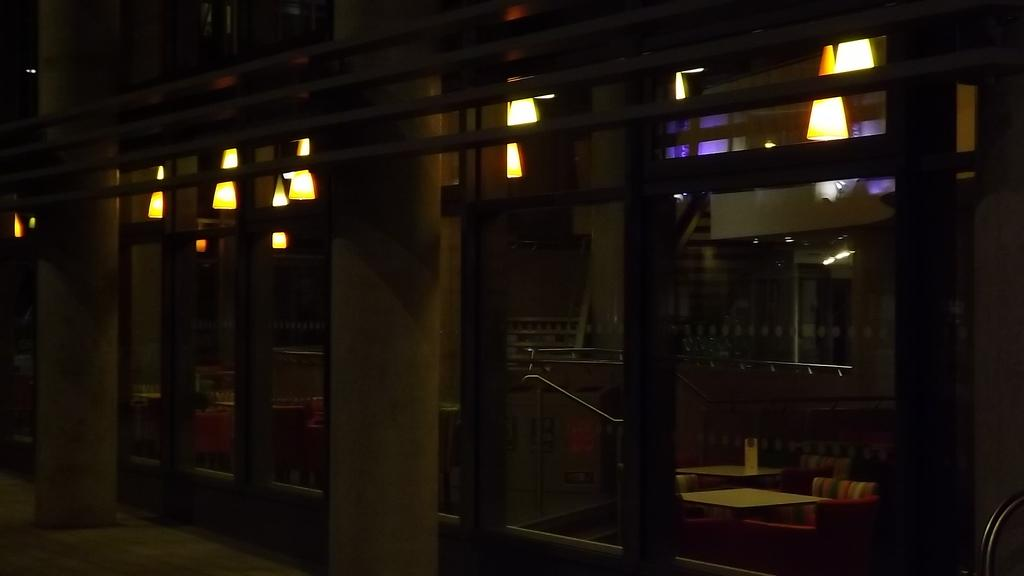What type of structures can be seen in the image? There are poles in the image. What type of entryway is present in the image? There are glass doors in the image. What can be seen behind the glass doors? Tables, a sofa, a railing, and lights are visible behind the glass doors. Where is the nest located in the image? There is no nest present in the image. What type of card is visible on the table behind the glass doors? There is no card visible on the table behind the glass doors. 